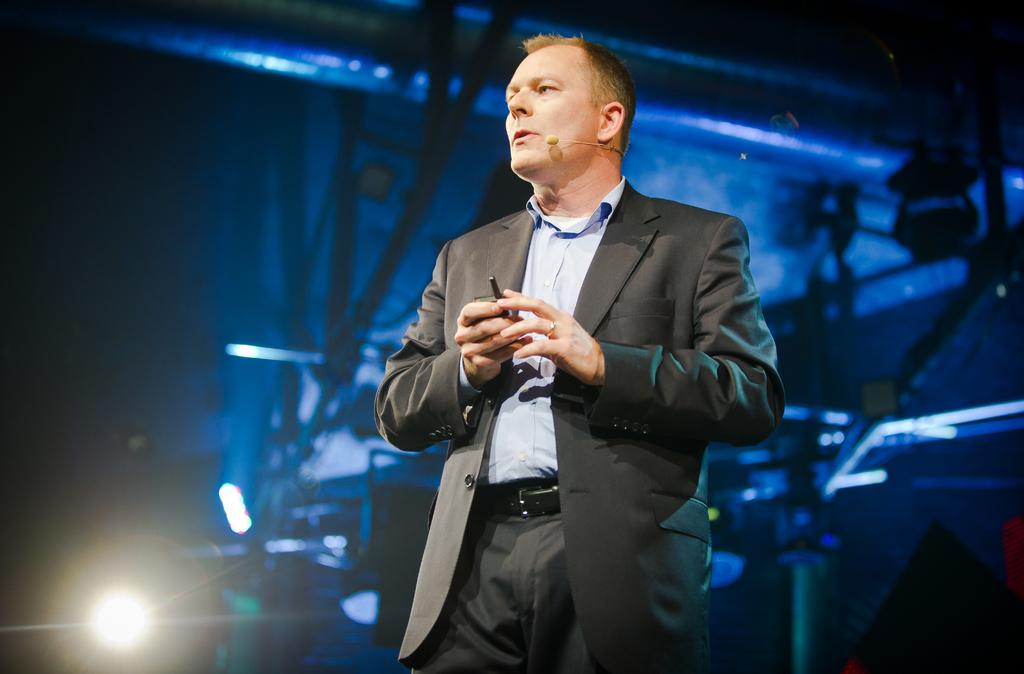What can be seen in the image? There is a person in the image. What is the person doing in the image? The person is holding an object. What can be seen in the background of the image? There is a light and other unspecified objects in the background of the image. What type of window can be seen in the image? There is no window present in the image. What genre of fiction is the person reading in the image? There is no book or any indication of reading in the image. 